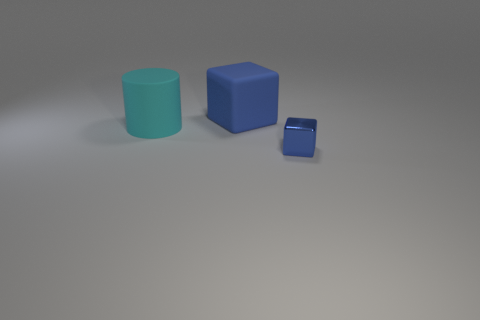Add 1 big red cubes. How many objects exist? 4 Subtract all blocks. How many objects are left? 1 Add 3 small blue metal things. How many small blue metal things are left? 4 Add 3 big cyan metallic objects. How many big cyan metallic objects exist? 3 Subtract 0 blue cylinders. How many objects are left? 3 Subtract all tiny blue shiny things. Subtract all big blue matte objects. How many objects are left? 1 